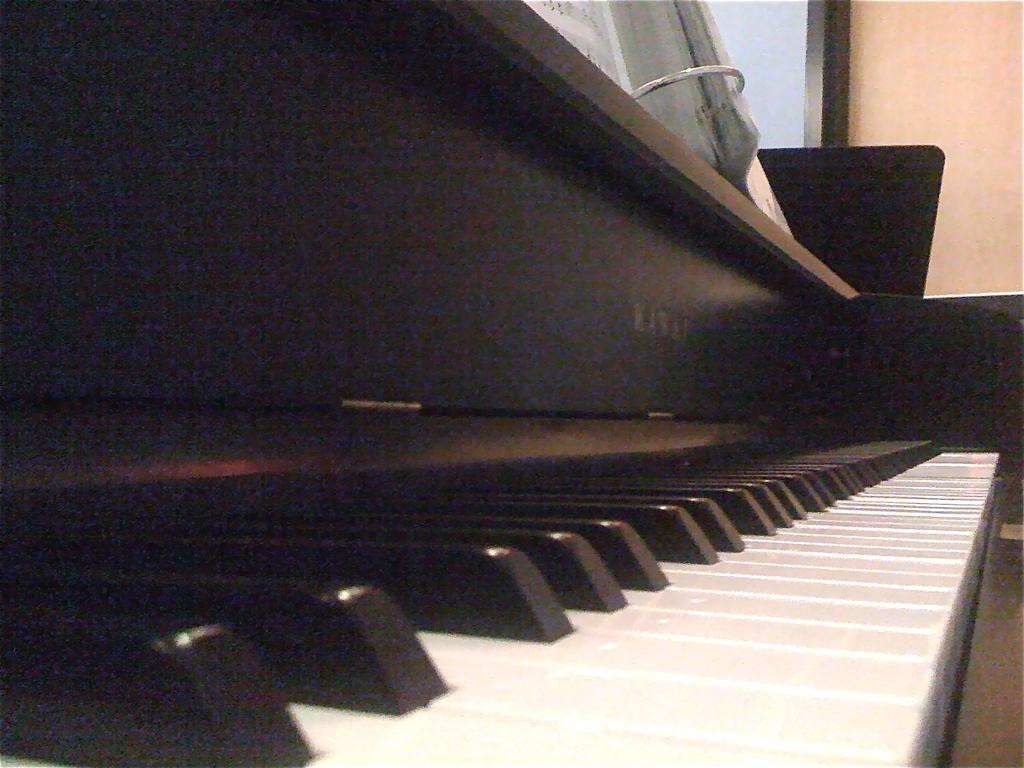What musical instrument is present in the image? There is a piano in the image. What type of keys does the piano have? The piano has black and white keys. Is the piano being played in the image? The image does not show whether the piano is being played or not. What might be the purpose of the piano in the image? The piano might be used for playing music or as a decorative piece. What is the weather like in the image? The image does not provide any information about the weather, as it only shows a piano. In what year was the piano manufactured? The image does not provide any information about the year the piano was manufactured. 